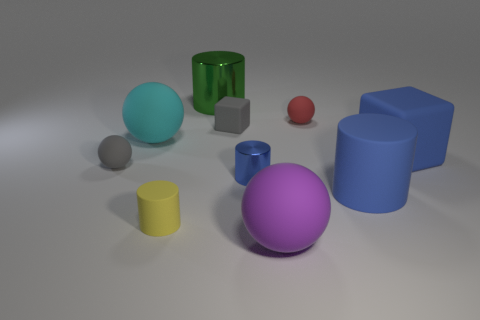What number of red objects are there?
Offer a very short reply. 1. There is a large blue matte cylinder that is on the right side of the red matte sphere; how many purple rubber spheres are right of it?
Ensure brevity in your answer.  0. There is a big rubber cylinder; is it the same color as the matte block in front of the big cyan rubber sphere?
Offer a terse response. Yes. What number of large green metal objects are the same shape as the large purple rubber object?
Your response must be concise. 0. There is a cylinder that is behind the tiny block; what material is it?
Your answer should be very brief. Metal. Do the metallic thing that is behind the large block and the small blue thing have the same shape?
Provide a succinct answer. Yes. Are there any cyan matte balls that have the same size as the yellow thing?
Your response must be concise. No. There is a large green metallic object; is it the same shape as the tiny rubber thing in front of the large rubber cylinder?
Offer a terse response. Yes. There is a tiny object that is the same color as the tiny cube; what is its shape?
Make the answer very short. Sphere. Are there fewer big purple spheres behind the big metallic cylinder than tiny red spheres?
Your response must be concise. Yes. 